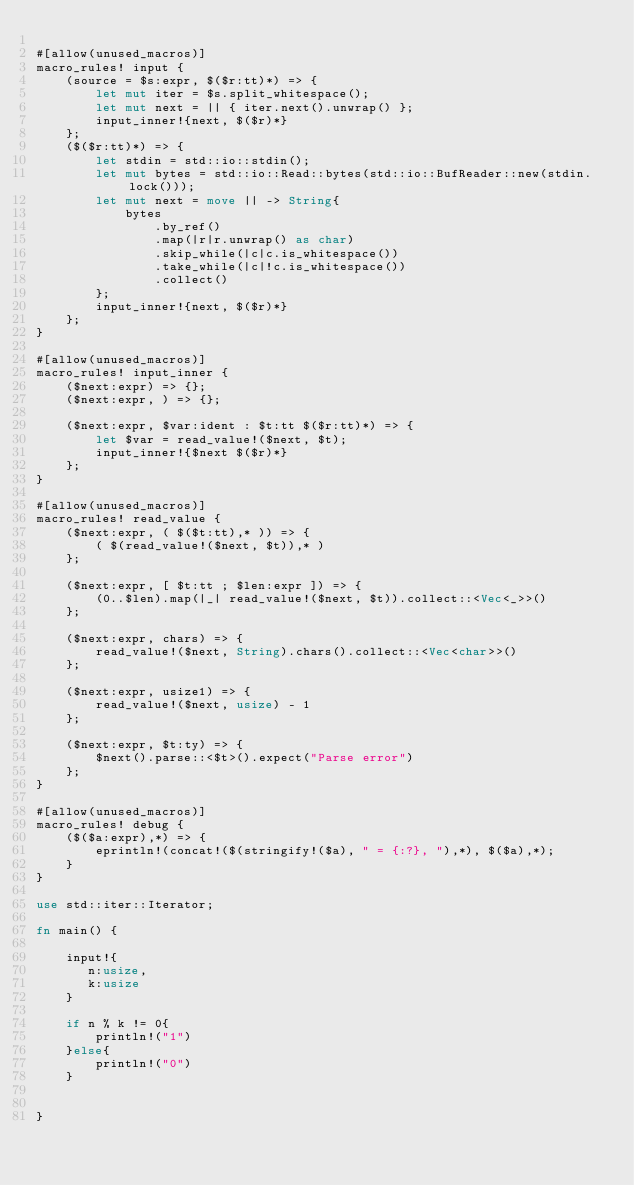Convert code to text. <code><loc_0><loc_0><loc_500><loc_500><_Rust_>
#[allow(unused_macros)]
macro_rules! input {
    (source = $s:expr, $($r:tt)*) => {
        let mut iter = $s.split_whitespace();
        let mut next = || { iter.next().unwrap() };
        input_inner!{next, $($r)*}
    };
    ($($r:tt)*) => {
        let stdin = std::io::stdin();
        let mut bytes = std::io::Read::bytes(std::io::BufReader::new(stdin.lock()));
        let mut next = move || -> String{
            bytes
                .by_ref()
                .map(|r|r.unwrap() as char)
                .skip_while(|c|c.is_whitespace())
                .take_while(|c|!c.is_whitespace())
                .collect()
        };
        input_inner!{next, $($r)*}
    };
}

#[allow(unused_macros)]
macro_rules! input_inner {
    ($next:expr) => {};
    ($next:expr, ) => {};

    ($next:expr, $var:ident : $t:tt $($r:tt)*) => {
        let $var = read_value!($next, $t);
        input_inner!{$next $($r)*}
    };
}

#[allow(unused_macros)]
macro_rules! read_value {
    ($next:expr, ( $($t:tt),* )) => {
        ( $(read_value!($next, $t)),* )
    };

    ($next:expr, [ $t:tt ; $len:expr ]) => {
        (0..$len).map(|_| read_value!($next, $t)).collect::<Vec<_>>()
    };

    ($next:expr, chars) => {
        read_value!($next, String).chars().collect::<Vec<char>>()
    };

    ($next:expr, usize1) => {
        read_value!($next, usize) - 1
    };

    ($next:expr, $t:ty) => {
        $next().parse::<$t>().expect("Parse error")
    };
}

#[allow(unused_macros)]
macro_rules! debug {
    ($($a:expr),*) => {
        eprintln!(concat!($(stringify!($a), " = {:?}, "),*), $($a),*);
    }
}

use std::iter::Iterator;

fn main() {

    input!{
       n:usize,
       k:usize
    }

    if n % k != 0{
        println!("1")
    }else{
        println!("0")
    }


}
</code> 